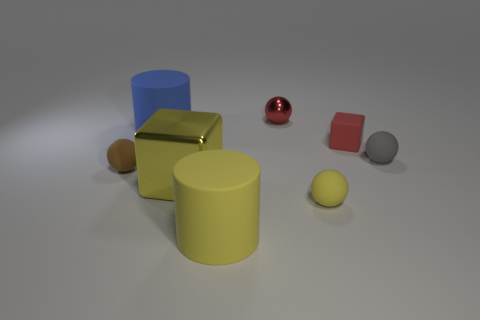Subtract all small gray spheres. How many spheres are left? 3 Add 1 big rubber things. How many objects exist? 9 Subtract 3 balls. How many balls are left? 1 Subtract all gray balls. How many balls are left? 3 Subtract all cylinders. How many objects are left? 6 Subtract all yellow cylinders. Subtract all brown cubes. How many cylinders are left? 1 Subtract all gray cubes. Subtract all small matte blocks. How many objects are left? 7 Add 1 tiny shiny things. How many tiny shiny things are left? 2 Add 6 yellow blocks. How many yellow blocks exist? 7 Subtract 0 gray blocks. How many objects are left? 8 